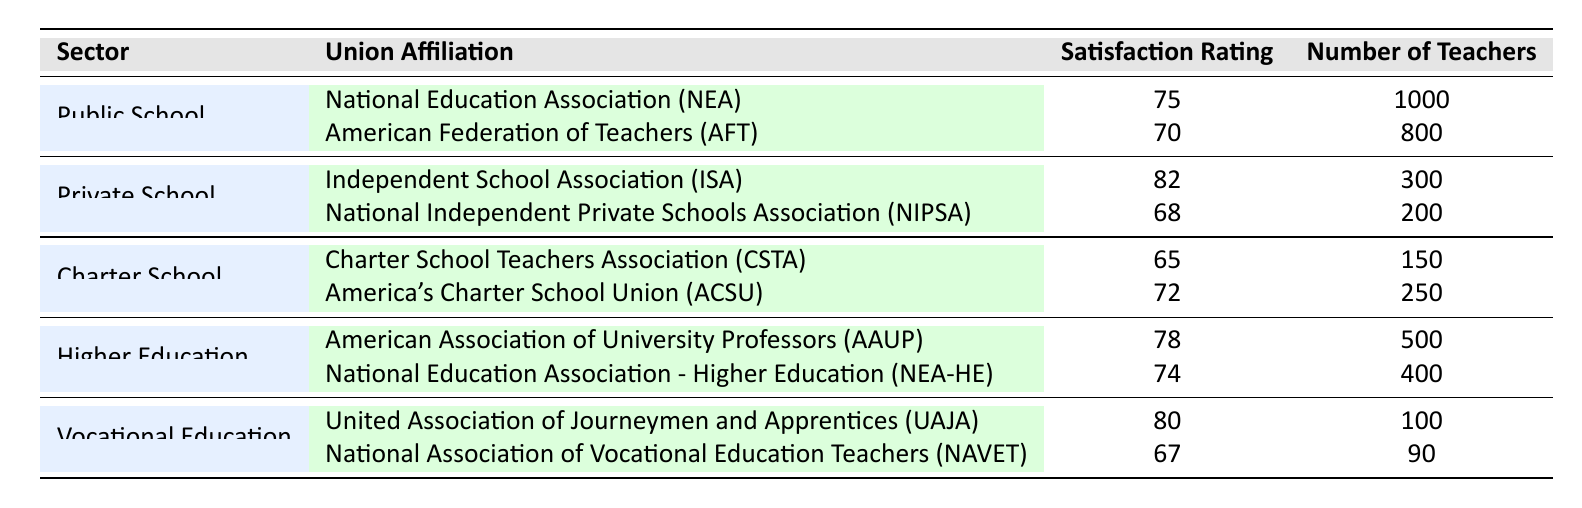What is the satisfaction rating for teachers in Private Schools affiliated with the Independent School Association? The table indicates that the satisfaction rating for teachers in Private Schools affiliated with the Independent School Association is 82.
Answer: 82 Which union has the highest satisfaction rating in the Public School sector? According to the table, the National Education Association (NEA) has the highest satisfaction rating in the Public School sector at 75.
Answer: National Education Association (NEA) What is the average satisfaction rating for teachers in Higher Education? The satisfaction ratings for Higher Education are 78 and 74. To find the average, we add these two values: 78 + 74 = 152, and then divide by 2: 152 / 2 = 76.
Answer: 76 Do teachers in Charter Schools affiliated with America’s Charter School Union have a higher satisfaction rating than those affiliated with the Charter School Teachers Association? The satisfaction rating for teachers in Charter Schools affiliated with America’s Charter School Union is 72, while that for the Charter School Teachers Association is 65. Since 72 is greater than 65, the statement is true.
Answer: Yes Which sector has the highest number of teachers with satisfaction ratings over 75? The Public School sector has the highest number of teachers with a satisfaction rating over 75 (1,000 teachers in NEA). Private School follows with 300 teachers in ISA, but Public School exceeds that with a higher count overall.
Answer: Public School What is the difference in satisfaction ratings between the highest-rated and lowest-rated unions in Vocational Education? The highest satisfaction rating in Vocational Education is 80 (UAJA) and the lowest is 67 (NAVET). The difference is calculated as: 80 - 67 = 13.
Answer: 13 Is it true that the satisfaction rating for teachers in Private Schools is generally higher than those in Charter Schools? In Private Schools, the satisfaction ratings are 82 and 68, averaging 75. In Charter Schools, the ratings are 65 and 72, averaging 68. Since 75 is greater than 68, the statement is true.
Answer: Yes Which union in Higher Education has more teachers and what is their satisfaction rating? The National Education Association - Higher Education (NEA-HE) has 400 teachers with a satisfaction rating of 74. This is less than the American Association of University Professors (AAUP) which has 500 teachers and a higher satisfaction rating of 78.
Answer: National Education Association - Higher Education, 74 How many teachers are there in total across all unions in Public Schools? In Public Schools, we have 1,000 teachers from NEA and 800 teachers from AFT. The total is 1,000 + 800 = 1,800 teachers.
Answer: 1,800 